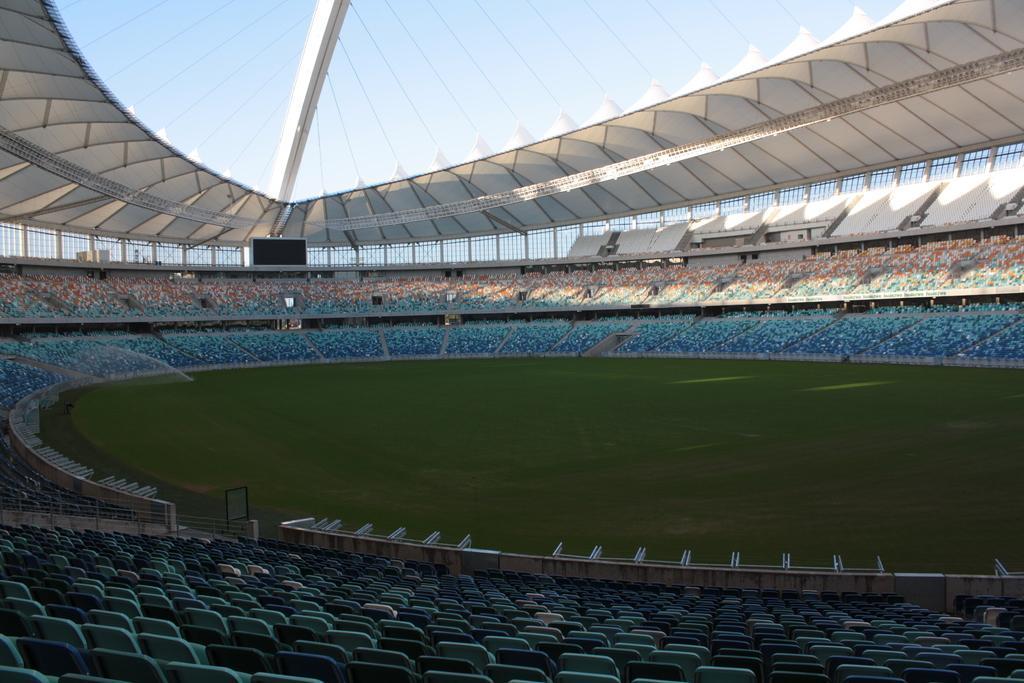Describe this image in one or two sentences. This picture is taken inside the stadium. In this image, we can see some chairs. In the background, we can see metal grill, black color board, we can also see the white color board. At the top, we can see some threads, roof and a sky, at the bottom, we can see a grass. 